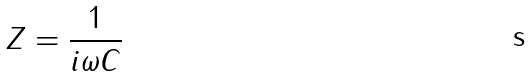<formula> <loc_0><loc_0><loc_500><loc_500>Z = \frac { 1 } { i \omega C }</formula> 